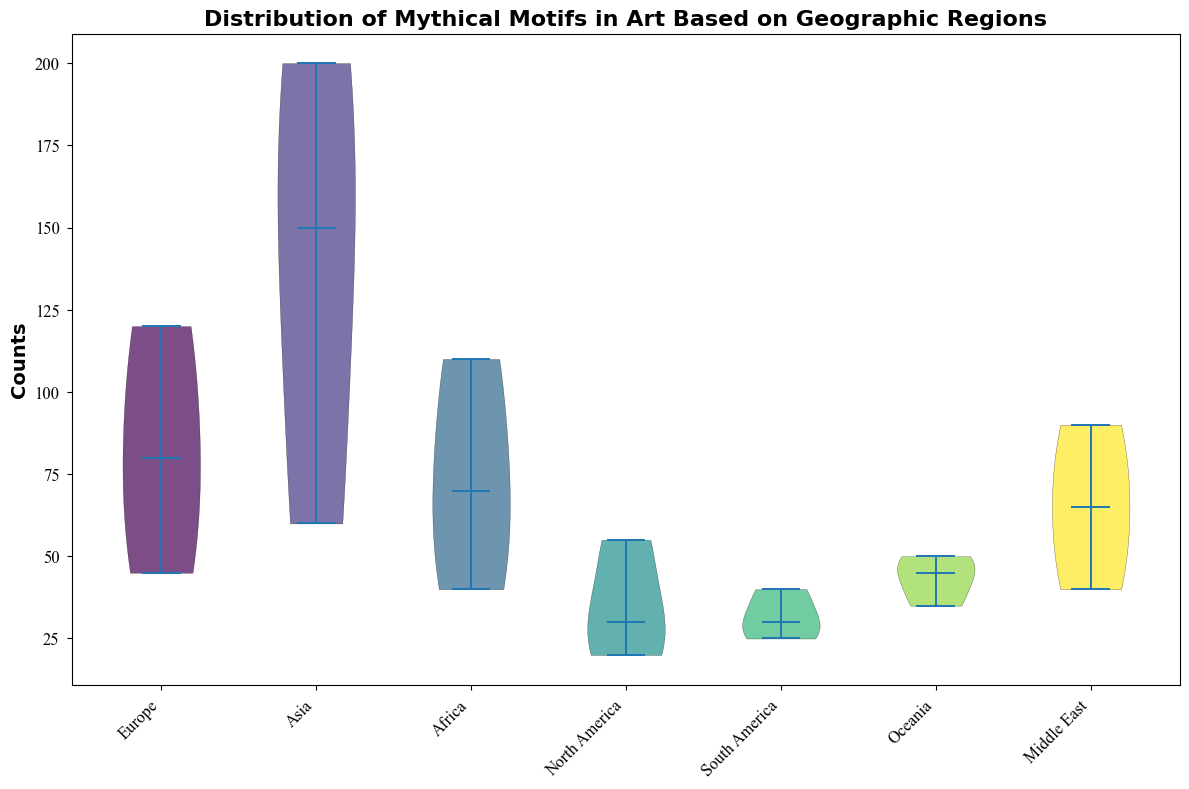What region has the highest median count of mythical motifs? By examining the plot, we can identify the median by the line inside each violin. The region with the highest median count clearly appears to belong to Asia.
Answer: Asia Which region shows the widest range in the distribution of mythical motifs? The width of the violins represents the spread of data. Comparing all violins, Asia shows the widest range, indicating the broadest spread of counts.
Answer: Asia Is the median count of motifs higher in Europe or Africa? Look at the median lines inside the violins for Europe and Africa, which are located at the center of each distribution. Europe has a slightly higher median count than Africa.
Answer: Europe Which region's distribution of motifs appears to be more varied in comparison to North America? Comparing the shapes and widths of the violins, both Europe and Asia exhibit more variation in their distributions compared to North America, which has a narrower and more compact distribution.
Answer: Europe, Asia What is the approximate median count of mythical motifs in the Middle East region? The median is represented by the horizontal line within the violin. For the Middle East region, the line appears to be around 65 counts.
Answer: 65 Based on the visualization, which region has the lowest overall count distribution of mythical motifs? By observing the lower ends of the violins, which represent the minima, both Oceania and North America exhibit generally low distributions in counts, but North America has the lowest maximum count, implying it has the overall lowest distribution.
Answer: North America Does Africa or the Middle East have more motifs with counts greater than 70? The distribution for Africa has a broader section above 70 compared to the Middle East, indicating more motifs with counts greater than 70 in Africa.
Answer: Africa Are the median counts for mythical motifs in Europe and North America significantly different? Comparing the median lines inside the violins for Europe and North America, Europe has a visibly higher median, showing a significant difference.
Answer: Yes How does the spread of mythical motifs in Oceania compare to that of South America? The width and spread of Oceania's violin is comparable to that of South America, suggesting similar variation in motif counts in both regions.
Answer: Similar Examine the color representation in the plot. Which regions have visually distinct colors? The regions are plotted with varying colors from the viridis color map. Visually distinct colors can be seen between regions like Europe (greenish), Asia (yellowish), and North America (purplish).
Answer: Europe, Asia, North America 